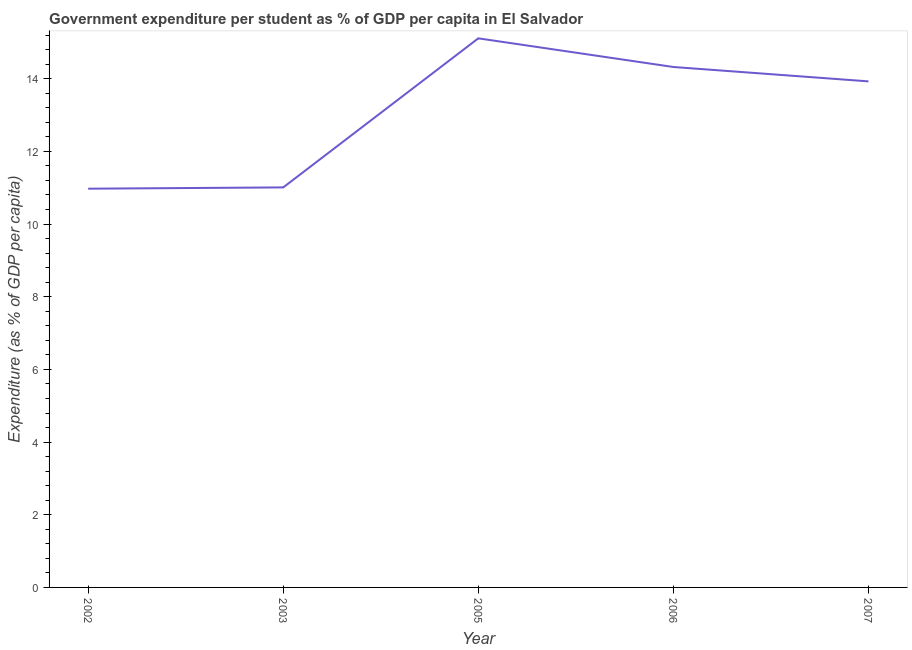What is the government expenditure per student in 2007?
Your response must be concise. 13.93. Across all years, what is the maximum government expenditure per student?
Your answer should be very brief. 15.11. Across all years, what is the minimum government expenditure per student?
Your answer should be compact. 10.97. In which year was the government expenditure per student maximum?
Provide a succinct answer. 2005. What is the sum of the government expenditure per student?
Provide a succinct answer. 65.34. What is the difference between the government expenditure per student in 2003 and 2006?
Ensure brevity in your answer.  -3.31. What is the average government expenditure per student per year?
Ensure brevity in your answer.  13.07. What is the median government expenditure per student?
Your response must be concise. 13.93. What is the ratio of the government expenditure per student in 2002 to that in 2006?
Offer a terse response. 0.77. Is the government expenditure per student in 2003 less than that in 2005?
Make the answer very short. Yes. Is the difference between the government expenditure per student in 2002 and 2005 greater than the difference between any two years?
Your answer should be very brief. Yes. What is the difference between the highest and the second highest government expenditure per student?
Your answer should be very brief. 0.79. Is the sum of the government expenditure per student in 2002 and 2005 greater than the maximum government expenditure per student across all years?
Offer a very short reply. Yes. What is the difference between the highest and the lowest government expenditure per student?
Ensure brevity in your answer.  4.14. In how many years, is the government expenditure per student greater than the average government expenditure per student taken over all years?
Make the answer very short. 3. How many lines are there?
Make the answer very short. 1. What is the difference between two consecutive major ticks on the Y-axis?
Your answer should be compact. 2. Does the graph contain any zero values?
Your answer should be very brief. No. What is the title of the graph?
Provide a short and direct response. Government expenditure per student as % of GDP per capita in El Salvador. What is the label or title of the X-axis?
Keep it short and to the point. Year. What is the label or title of the Y-axis?
Make the answer very short. Expenditure (as % of GDP per capita). What is the Expenditure (as % of GDP per capita) of 2002?
Give a very brief answer. 10.97. What is the Expenditure (as % of GDP per capita) of 2003?
Your answer should be very brief. 11.01. What is the Expenditure (as % of GDP per capita) of 2005?
Ensure brevity in your answer.  15.11. What is the Expenditure (as % of GDP per capita) of 2006?
Your answer should be compact. 14.32. What is the Expenditure (as % of GDP per capita) of 2007?
Your answer should be very brief. 13.93. What is the difference between the Expenditure (as % of GDP per capita) in 2002 and 2003?
Your answer should be compact. -0.04. What is the difference between the Expenditure (as % of GDP per capita) in 2002 and 2005?
Make the answer very short. -4.14. What is the difference between the Expenditure (as % of GDP per capita) in 2002 and 2006?
Your response must be concise. -3.35. What is the difference between the Expenditure (as % of GDP per capita) in 2002 and 2007?
Offer a very short reply. -2.95. What is the difference between the Expenditure (as % of GDP per capita) in 2003 and 2005?
Your response must be concise. -4.1. What is the difference between the Expenditure (as % of GDP per capita) in 2003 and 2006?
Ensure brevity in your answer.  -3.31. What is the difference between the Expenditure (as % of GDP per capita) in 2003 and 2007?
Provide a short and direct response. -2.92. What is the difference between the Expenditure (as % of GDP per capita) in 2005 and 2006?
Offer a very short reply. 0.79. What is the difference between the Expenditure (as % of GDP per capita) in 2005 and 2007?
Offer a terse response. 1.18. What is the difference between the Expenditure (as % of GDP per capita) in 2006 and 2007?
Your response must be concise. 0.4. What is the ratio of the Expenditure (as % of GDP per capita) in 2002 to that in 2005?
Keep it short and to the point. 0.73. What is the ratio of the Expenditure (as % of GDP per capita) in 2002 to that in 2006?
Provide a short and direct response. 0.77. What is the ratio of the Expenditure (as % of GDP per capita) in 2002 to that in 2007?
Make the answer very short. 0.79. What is the ratio of the Expenditure (as % of GDP per capita) in 2003 to that in 2005?
Keep it short and to the point. 0.73. What is the ratio of the Expenditure (as % of GDP per capita) in 2003 to that in 2006?
Make the answer very short. 0.77. What is the ratio of the Expenditure (as % of GDP per capita) in 2003 to that in 2007?
Provide a short and direct response. 0.79. What is the ratio of the Expenditure (as % of GDP per capita) in 2005 to that in 2006?
Offer a terse response. 1.05. What is the ratio of the Expenditure (as % of GDP per capita) in 2005 to that in 2007?
Provide a short and direct response. 1.08. What is the ratio of the Expenditure (as % of GDP per capita) in 2006 to that in 2007?
Offer a terse response. 1.03. 